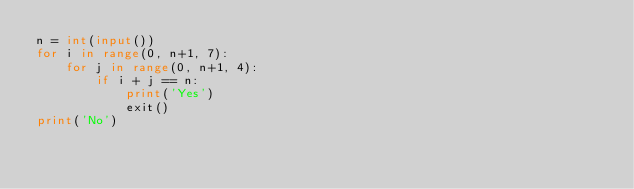Convert code to text. <code><loc_0><loc_0><loc_500><loc_500><_Python_>n = int(input())
for i in range(0, n+1, 7):
    for j in range(0, n+1, 4):
        if i + j == n:
            print('Yes')
            exit()
print('No')</code> 